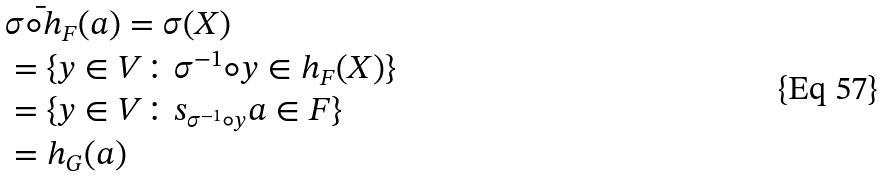Convert formula to latex. <formula><loc_0><loc_0><loc_500><loc_500>& \bar { \sigma \circ h _ { F } } ( a ) = \sigma ( X ) \\ & = \{ y \in V \colon \sigma ^ { - 1 } \circ y \in h _ { F } ( X ) \} \\ & = \{ y \in V \colon s _ { \sigma ^ { - 1 } \circ y } a \in F \} \\ & = h _ { G } ( a ) \\</formula> 